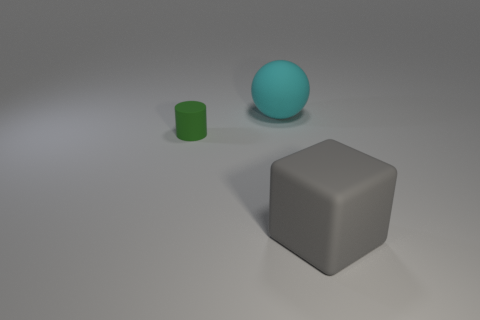Add 3 large gray rubber blocks. How many objects exist? 6 Subtract all spheres. How many objects are left? 2 Add 2 green things. How many green things are left? 3 Add 1 big yellow rubber objects. How many big yellow rubber objects exist? 1 Subtract 0 purple spheres. How many objects are left? 3 Subtract all tiny cyan shiny blocks. Subtract all green objects. How many objects are left? 2 